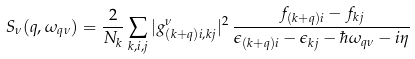Convert formula to latex. <formula><loc_0><loc_0><loc_500><loc_500>S _ { \nu } ( { q } , \omega _ { { q } \nu } ) = \frac { 2 } { N _ { k } } \sum _ { { k } , i , j } | g _ { ( { k + q } ) i , { k } j } ^ { \nu } | ^ { 2 } \, \frac { f _ { ( { k } + { q } ) i } - f _ { { k } j } } { \epsilon _ { ( { k } + { q } ) i } - \epsilon _ { { k } j } - \hbar { \omega } _ { { q } \nu } - i \eta }</formula> 